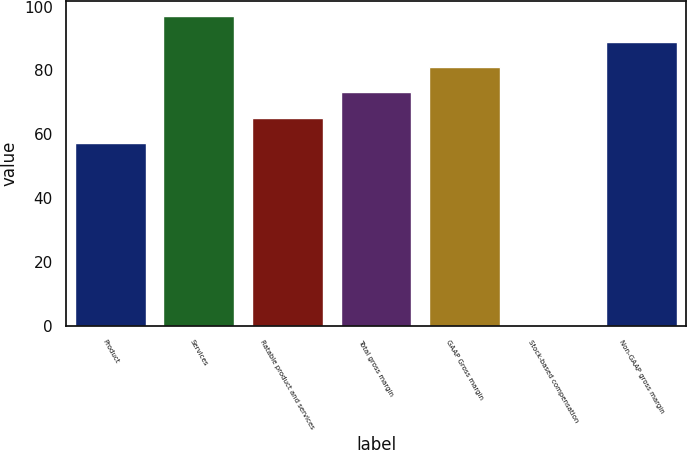<chart> <loc_0><loc_0><loc_500><loc_500><bar_chart><fcel>Product<fcel>Services<fcel>Ratable product and services<fcel>Total gross margin<fcel>GAAP Gross margin<fcel>Stock-based compensation<fcel>Non-GAAP gross margin<nl><fcel>57.2<fcel>96.95<fcel>65.15<fcel>73.1<fcel>81.05<fcel>0.2<fcel>89<nl></chart> 